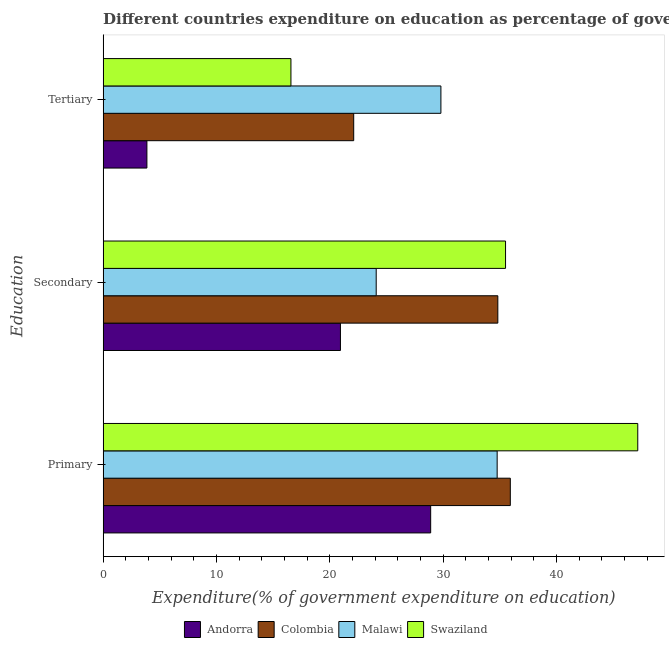How many different coloured bars are there?
Give a very brief answer. 4. How many groups of bars are there?
Provide a short and direct response. 3. Are the number of bars on each tick of the Y-axis equal?
Your response must be concise. Yes. What is the label of the 2nd group of bars from the top?
Ensure brevity in your answer.  Secondary. What is the expenditure on tertiary education in Colombia?
Provide a succinct answer. 22.11. Across all countries, what is the maximum expenditure on tertiary education?
Offer a terse response. 29.8. Across all countries, what is the minimum expenditure on primary education?
Your answer should be compact. 28.9. In which country was the expenditure on tertiary education maximum?
Keep it short and to the point. Malawi. In which country was the expenditure on primary education minimum?
Provide a short and direct response. Andorra. What is the total expenditure on tertiary education in the graph?
Your answer should be compact. 72.33. What is the difference between the expenditure on secondary education in Swaziland and that in Andorra?
Offer a terse response. 14.57. What is the difference between the expenditure on primary education in Andorra and the expenditure on secondary education in Malawi?
Provide a succinct answer. 4.81. What is the average expenditure on tertiary education per country?
Your answer should be compact. 18.08. What is the difference between the expenditure on tertiary education and expenditure on primary education in Malawi?
Ensure brevity in your answer.  -4.96. In how many countries, is the expenditure on secondary education greater than 44 %?
Offer a very short reply. 0. What is the ratio of the expenditure on tertiary education in Colombia to that in Malawi?
Provide a succinct answer. 0.74. Is the difference between the expenditure on primary education in Malawi and Swaziland greater than the difference between the expenditure on secondary education in Malawi and Swaziland?
Make the answer very short. No. What is the difference between the highest and the second highest expenditure on primary education?
Keep it short and to the point. 11.24. What is the difference between the highest and the lowest expenditure on secondary education?
Give a very brief answer. 14.57. In how many countries, is the expenditure on primary education greater than the average expenditure on primary education taken over all countries?
Give a very brief answer. 1. What does the 4th bar from the top in Primary represents?
Give a very brief answer. Andorra. What does the 4th bar from the bottom in Tertiary represents?
Your answer should be very brief. Swaziland. Is it the case that in every country, the sum of the expenditure on primary education and expenditure on secondary education is greater than the expenditure on tertiary education?
Your response must be concise. Yes. Does the graph contain grids?
Make the answer very short. No. Where does the legend appear in the graph?
Give a very brief answer. Bottom center. How are the legend labels stacked?
Offer a very short reply. Horizontal. What is the title of the graph?
Keep it short and to the point. Different countries expenditure on education as percentage of government expenditure. Does "Sierra Leone" appear as one of the legend labels in the graph?
Offer a terse response. No. What is the label or title of the X-axis?
Provide a short and direct response. Expenditure(% of government expenditure on education). What is the label or title of the Y-axis?
Make the answer very short. Education. What is the Expenditure(% of government expenditure on education) in Andorra in Primary?
Make the answer very short. 28.9. What is the Expenditure(% of government expenditure on education) of Colombia in Primary?
Provide a short and direct response. 35.92. What is the Expenditure(% of government expenditure on education) in Malawi in Primary?
Provide a short and direct response. 34.76. What is the Expenditure(% of government expenditure on education) in Swaziland in Primary?
Give a very brief answer. 47.16. What is the Expenditure(% of government expenditure on education) of Andorra in Secondary?
Offer a terse response. 20.93. What is the Expenditure(% of government expenditure on education) in Colombia in Secondary?
Give a very brief answer. 34.82. What is the Expenditure(% of government expenditure on education) in Malawi in Secondary?
Ensure brevity in your answer.  24.09. What is the Expenditure(% of government expenditure on education) of Swaziland in Secondary?
Provide a succinct answer. 35.5. What is the Expenditure(% of government expenditure on education) of Andorra in Tertiary?
Keep it short and to the point. 3.86. What is the Expenditure(% of government expenditure on education) of Colombia in Tertiary?
Offer a terse response. 22.11. What is the Expenditure(% of government expenditure on education) of Malawi in Tertiary?
Your answer should be compact. 29.8. What is the Expenditure(% of government expenditure on education) of Swaziland in Tertiary?
Give a very brief answer. 16.57. Across all Education, what is the maximum Expenditure(% of government expenditure on education) of Andorra?
Your answer should be compact. 28.9. Across all Education, what is the maximum Expenditure(% of government expenditure on education) of Colombia?
Keep it short and to the point. 35.92. Across all Education, what is the maximum Expenditure(% of government expenditure on education) in Malawi?
Your answer should be very brief. 34.76. Across all Education, what is the maximum Expenditure(% of government expenditure on education) in Swaziland?
Offer a very short reply. 47.16. Across all Education, what is the minimum Expenditure(% of government expenditure on education) in Andorra?
Your response must be concise. 3.86. Across all Education, what is the minimum Expenditure(% of government expenditure on education) of Colombia?
Provide a succinct answer. 22.11. Across all Education, what is the minimum Expenditure(% of government expenditure on education) of Malawi?
Make the answer very short. 24.09. Across all Education, what is the minimum Expenditure(% of government expenditure on education) in Swaziland?
Your response must be concise. 16.57. What is the total Expenditure(% of government expenditure on education) in Andorra in the graph?
Your answer should be very brief. 53.69. What is the total Expenditure(% of government expenditure on education) in Colombia in the graph?
Your response must be concise. 92.85. What is the total Expenditure(% of government expenditure on education) in Malawi in the graph?
Give a very brief answer. 88.65. What is the total Expenditure(% of government expenditure on education) in Swaziland in the graph?
Provide a short and direct response. 99.23. What is the difference between the Expenditure(% of government expenditure on education) in Andorra in Primary and that in Secondary?
Your response must be concise. 7.96. What is the difference between the Expenditure(% of government expenditure on education) in Colombia in Primary and that in Secondary?
Make the answer very short. 1.1. What is the difference between the Expenditure(% of government expenditure on education) in Malawi in Primary and that in Secondary?
Offer a very short reply. 10.67. What is the difference between the Expenditure(% of government expenditure on education) in Swaziland in Primary and that in Secondary?
Your response must be concise. 11.66. What is the difference between the Expenditure(% of government expenditure on education) of Andorra in Primary and that in Tertiary?
Your answer should be very brief. 25.03. What is the difference between the Expenditure(% of government expenditure on education) in Colombia in Primary and that in Tertiary?
Provide a succinct answer. 13.82. What is the difference between the Expenditure(% of government expenditure on education) in Malawi in Primary and that in Tertiary?
Offer a terse response. 4.96. What is the difference between the Expenditure(% of government expenditure on education) of Swaziland in Primary and that in Tertiary?
Your response must be concise. 30.6. What is the difference between the Expenditure(% of government expenditure on education) of Andorra in Secondary and that in Tertiary?
Your answer should be very brief. 17.07. What is the difference between the Expenditure(% of government expenditure on education) in Colombia in Secondary and that in Tertiary?
Offer a very short reply. 12.71. What is the difference between the Expenditure(% of government expenditure on education) in Malawi in Secondary and that in Tertiary?
Provide a short and direct response. -5.71. What is the difference between the Expenditure(% of government expenditure on education) of Swaziland in Secondary and that in Tertiary?
Your response must be concise. 18.93. What is the difference between the Expenditure(% of government expenditure on education) of Andorra in Primary and the Expenditure(% of government expenditure on education) of Colombia in Secondary?
Provide a succinct answer. -5.92. What is the difference between the Expenditure(% of government expenditure on education) in Andorra in Primary and the Expenditure(% of government expenditure on education) in Malawi in Secondary?
Make the answer very short. 4.81. What is the difference between the Expenditure(% of government expenditure on education) of Andorra in Primary and the Expenditure(% of government expenditure on education) of Swaziland in Secondary?
Provide a succinct answer. -6.6. What is the difference between the Expenditure(% of government expenditure on education) of Colombia in Primary and the Expenditure(% of government expenditure on education) of Malawi in Secondary?
Make the answer very short. 11.83. What is the difference between the Expenditure(% of government expenditure on education) of Colombia in Primary and the Expenditure(% of government expenditure on education) of Swaziland in Secondary?
Offer a terse response. 0.42. What is the difference between the Expenditure(% of government expenditure on education) in Malawi in Primary and the Expenditure(% of government expenditure on education) in Swaziland in Secondary?
Your answer should be compact. -0.74. What is the difference between the Expenditure(% of government expenditure on education) of Andorra in Primary and the Expenditure(% of government expenditure on education) of Colombia in Tertiary?
Ensure brevity in your answer.  6.79. What is the difference between the Expenditure(% of government expenditure on education) in Andorra in Primary and the Expenditure(% of government expenditure on education) in Malawi in Tertiary?
Offer a terse response. -0.9. What is the difference between the Expenditure(% of government expenditure on education) in Andorra in Primary and the Expenditure(% of government expenditure on education) in Swaziland in Tertiary?
Offer a terse response. 12.33. What is the difference between the Expenditure(% of government expenditure on education) in Colombia in Primary and the Expenditure(% of government expenditure on education) in Malawi in Tertiary?
Make the answer very short. 6.12. What is the difference between the Expenditure(% of government expenditure on education) in Colombia in Primary and the Expenditure(% of government expenditure on education) in Swaziland in Tertiary?
Offer a very short reply. 19.35. What is the difference between the Expenditure(% of government expenditure on education) in Malawi in Primary and the Expenditure(% of government expenditure on education) in Swaziland in Tertiary?
Your answer should be compact. 18.19. What is the difference between the Expenditure(% of government expenditure on education) in Andorra in Secondary and the Expenditure(% of government expenditure on education) in Colombia in Tertiary?
Provide a short and direct response. -1.17. What is the difference between the Expenditure(% of government expenditure on education) of Andorra in Secondary and the Expenditure(% of government expenditure on education) of Malawi in Tertiary?
Provide a short and direct response. -8.86. What is the difference between the Expenditure(% of government expenditure on education) in Andorra in Secondary and the Expenditure(% of government expenditure on education) in Swaziland in Tertiary?
Your answer should be compact. 4.37. What is the difference between the Expenditure(% of government expenditure on education) in Colombia in Secondary and the Expenditure(% of government expenditure on education) in Malawi in Tertiary?
Make the answer very short. 5.02. What is the difference between the Expenditure(% of government expenditure on education) of Colombia in Secondary and the Expenditure(% of government expenditure on education) of Swaziland in Tertiary?
Keep it short and to the point. 18.25. What is the difference between the Expenditure(% of government expenditure on education) of Malawi in Secondary and the Expenditure(% of government expenditure on education) of Swaziland in Tertiary?
Provide a short and direct response. 7.52. What is the average Expenditure(% of government expenditure on education) in Andorra per Education?
Your answer should be compact. 17.9. What is the average Expenditure(% of government expenditure on education) in Colombia per Education?
Offer a very short reply. 30.95. What is the average Expenditure(% of government expenditure on education) in Malawi per Education?
Your answer should be compact. 29.55. What is the average Expenditure(% of government expenditure on education) of Swaziland per Education?
Offer a very short reply. 33.08. What is the difference between the Expenditure(% of government expenditure on education) in Andorra and Expenditure(% of government expenditure on education) in Colombia in Primary?
Make the answer very short. -7.03. What is the difference between the Expenditure(% of government expenditure on education) in Andorra and Expenditure(% of government expenditure on education) in Malawi in Primary?
Provide a short and direct response. -5.87. What is the difference between the Expenditure(% of government expenditure on education) of Andorra and Expenditure(% of government expenditure on education) of Swaziland in Primary?
Offer a very short reply. -18.27. What is the difference between the Expenditure(% of government expenditure on education) in Colombia and Expenditure(% of government expenditure on education) in Malawi in Primary?
Your answer should be very brief. 1.16. What is the difference between the Expenditure(% of government expenditure on education) of Colombia and Expenditure(% of government expenditure on education) of Swaziland in Primary?
Make the answer very short. -11.24. What is the difference between the Expenditure(% of government expenditure on education) of Malawi and Expenditure(% of government expenditure on education) of Swaziland in Primary?
Your answer should be very brief. -12.4. What is the difference between the Expenditure(% of government expenditure on education) of Andorra and Expenditure(% of government expenditure on education) of Colombia in Secondary?
Your answer should be very brief. -13.89. What is the difference between the Expenditure(% of government expenditure on education) in Andorra and Expenditure(% of government expenditure on education) in Malawi in Secondary?
Your answer should be very brief. -3.16. What is the difference between the Expenditure(% of government expenditure on education) in Andorra and Expenditure(% of government expenditure on education) in Swaziland in Secondary?
Offer a very short reply. -14.57. What is the difference between the Expenditure(% of government expenditure on education) of Colombia and Expenditure(% of government expenditure on education) of Malawi in Secondary?
Make the answer very short. 10.73. What is the difference between the Expenditure(% of government expenditure on education) in Colombia and Expenditure(% of government expenditure on education) in Swaziland in Secondary?
Your answer should be compact. -0.68. What is the difference between the Expenditure(% of government expenditure on education) of Malawi and Expenditure(% of government expenditure on education) of Swaziland in Secondary?
Ensure brevity in your answer.  -11.41. What is the difference between the Expenditure(% of government expenditure on education) of Andorra and Expenditure(% of government expenditure on education) of Colombia in Tertiary?
Your answer should be very brief. -18.24. What is the difference between the Expenditure(% of government expenditure on education) of Andorra and Expenditure(% of government expenditure on education) of Malawi in Tertiary?
Provide a short and direct response. -25.94. What is the difference between the Expenditure(% of government expenditure on education) of Andorra and Expenditure(% of government expenditure on education) of Swaziland in Tertiary?
Your response must be concise. -12.71. What is the difference between the Expenditure(% of government expenditure on education) of Colombia and Expenditure(% of government expenditure on education) of Malawi in Tertiary?
Offer a very short reply. -7.69. What is the difference between the Expenditure(% of government expenditure on education) in Colombia and Expenditure(% of government expenditure on education) in Swaziland in Tertiary?
Your response must be concise. 5.54. What is the difference between the Expenditure(% of government expenditure on education) of Malawi and Expenditure(% of government expenditure on education) of Swaziland in Tertiary?
Offer a very short reply. 13.23. What is the ratio of the Expenditure(% of government expenditure on education) of Andorra in Primary to that in Secondary?
Make the answer very short. 1.38. What is the ratio of the Expenditure(% of government expenditure on education) of Colombia in Primary to that in Secondary?
Your answer should be compact. 1.03. What is the ratio of the Expenditure(% of government expenditure on education) in Malawi in Primary to that in Secondary?
Make the answer very short. 1.44. What is the ratio of the Expenditure(% of government expenditure on education) of Swaziland in Primary to that in Secondary?
Your answer should be very brief. 1.33. What is the ratio of the Expenditure(% of government expenditure on education) in Andorra in Primary to that in Tertiary?
Make the answer very short. 7.48. What is the ratio of the Expenditure(% of government expenditure on education) of Colombia in Primary to that in Tertiary?
Offer a terse response. 1.62. What is the ratio of the Expenditure(% of government expenditure on education) in Malawi in Primary to that in Tertiary?
Your response must be concise. 1.17. What is the ratio of the Expenditure(% of government expenditure on education) of Swaziland in Primary to that in Tertiary?
Ensure brevity in your answer.  2.85. What is the ratio of the Expenditure(% of government expenditure on education) in Andorra in Secondary to that in Tertiary?
Make the answer very short. 5.42. What is the ratio of the Expenditure(% of government expenditure on education) in Colombia in Secondary to that in Tertiary?
Provide a short and direct response. 1.58. What is the ratio of the Expenditure(% of government expenditure on education) in Malawi in Secondary to that in Tertiary?
Keep it short and to the point. 0.81. What is the ratio of the Expenditure(% of government expenditure on education) in Swaziland in Secondary to that in Tertiary?
Offer a terse response. 2.14. What is the difference between the highest and the second highest Expenditure(% of government expenditure on education) in Andorra?
Provide a succinct answer. 7.96. What is the difference between the highest and the second highest Expenditure(% of government expenditure on education) of Colombia?
Your response must be concise. 1.1. What is the difference between the highest and the second highest Expenditure(% of government expenditure on education) of Malawi?
Offer a very short reply. 4.96. What is the difference between the highest and the second highest Expenditure(% of government expenditure on education) in Swaziland?
Keep it short and to the point. 11.66. What is the difference between the highest and the lowest Expenditure(% of government expenditure on education) of Andorra?
Provide a succinct answer. 25.03. What is the difference between the highest and the lowest Expenditure(% of government expenditure on education) of Colombia?
Keep it short and to the point. 13.82. What is the difference between the highest and the lowest Expenditure(% of government expenditure on education) of Malawi?
Keep it short and to the point. 10.67. What is the difference between the highest and the lowest Expenditure(% of government expenditure on education) in Swaziland?
Give a very brief answer. 30.6. 